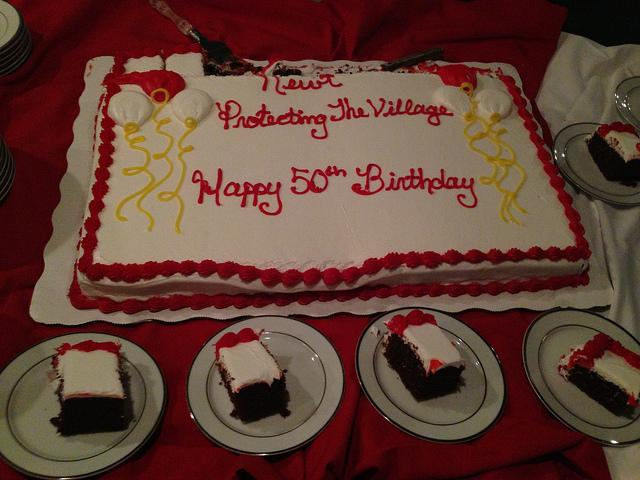The birthday boy has a name that refers to what kind of animal? Please explain your reasoning. salamander. The name is "newt". newts are a species of salamanders. 